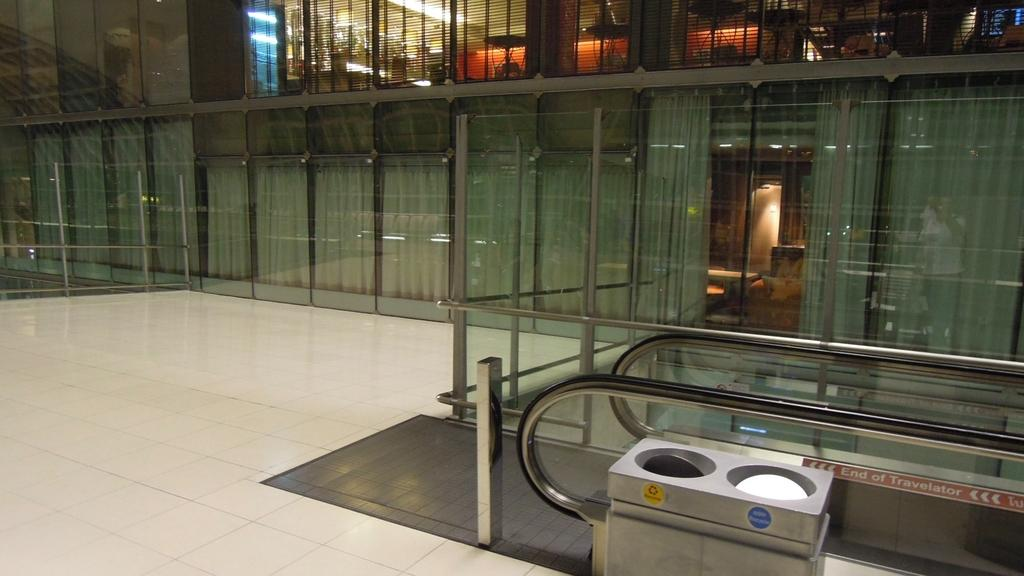<image>
Describe the image concisely. An escalator that says end of travelator on the side rail in a building next to glass windows 